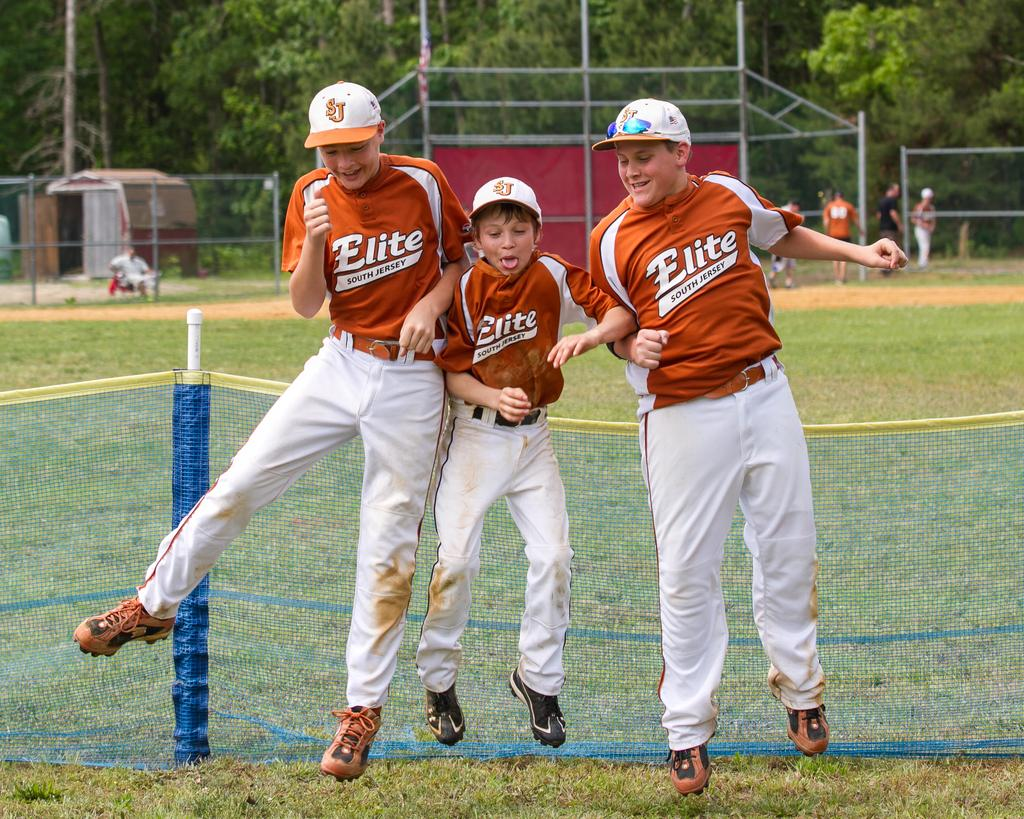Provide a one-sentence caption for the provided image. Three young Elite south jersey baseball player in red and white side by side jumping. 